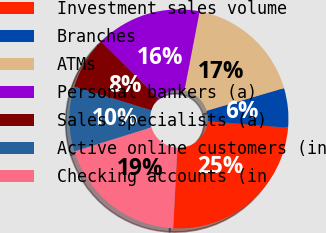<chart> <loc_0><loc_0><loc_500><loc_500><pie_chart><fcel>Investment sales volume<fcel>Branches<fcel>ATMs<fcel>Personal bankers (a)<fcel>Sales specialists (a)<fcel>Active online customers (in<fcel>Checking accounts (in<nl><fcel>24.55%<fcel>5.82%<fcel>17.44%<fcel>15.57%<fcel>7.69%<fcel>9.56%<fcel>19.37%<nl></chart> 